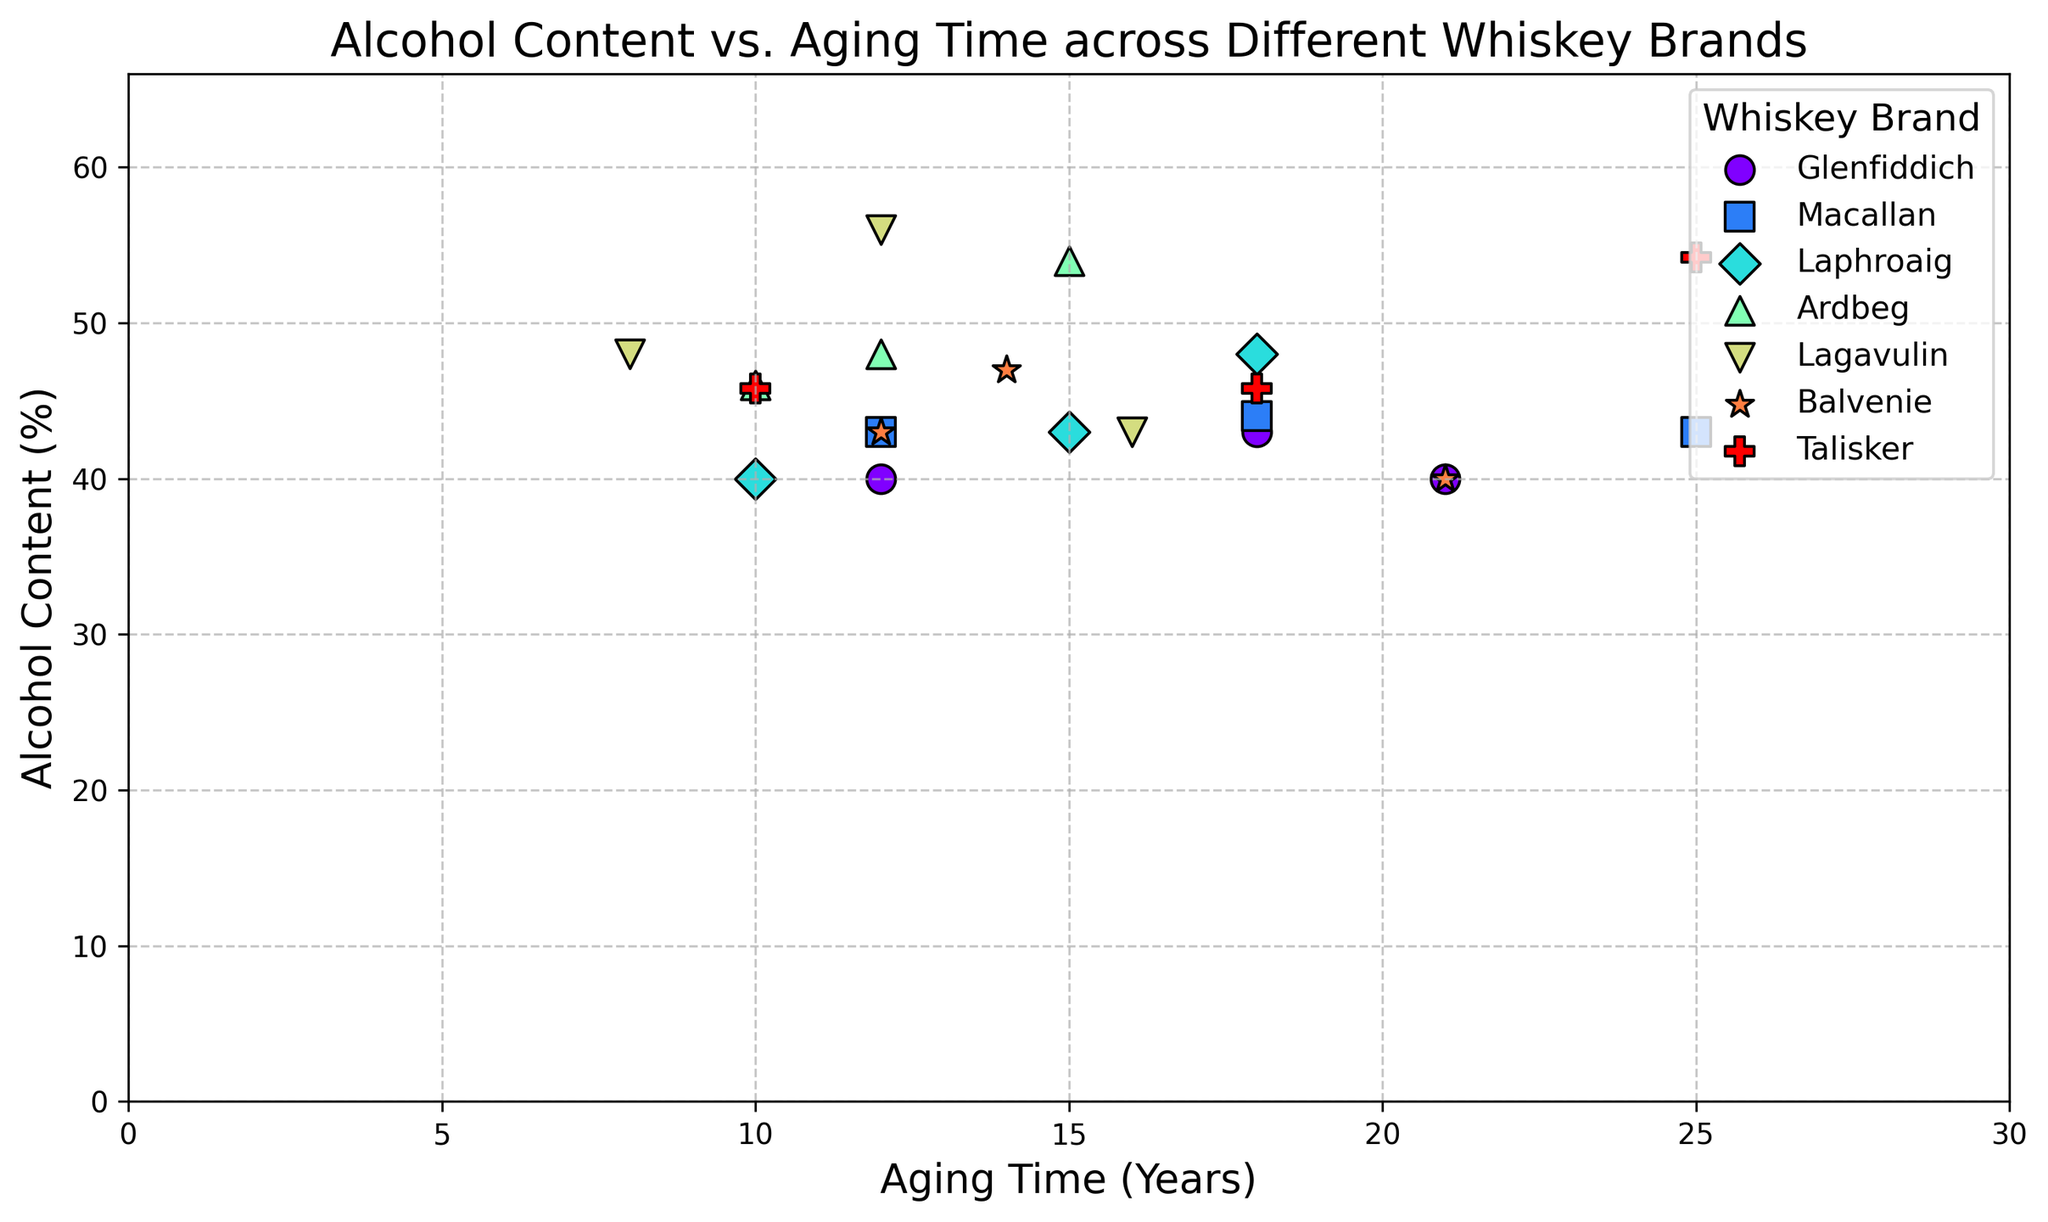What's the brand with the highest alcohol content? Among the plotted points, find and compare the highest y-axis value (Alcohol Content). Identifying Lagavulin with an alcohol content of 56% at 12 years aging.
Answer: Lagavulin Which whiskey brand has the most consistent alcohol content across different aging times? Consistency can be visually assessed by identifying the brand with points closely clustered along the y-axis. Talisker maintains an alcohol content around 45.8% throughout.
Answer: Talisker What is the average alcohol content of Glenfiddich whiskies? Glenfiddich has alcohol contents of 40%, 43%, and 40%. The average is calculated as (40+43+40)/3.
Answer: 41% Is there a brand where older whiskies also have higher alcohol content? Check the trend for each brand, observing if alcohol content increases with aging time. Lagavulin shows a rise from 48% at 8 years to 56% at 12 years, then drops at 16 years.
Answer: Lagavulin Which has higher alcohol content at 12 years, Macallan or Balvenie? Compare the y-axis values for 12-year-old Macallan (43%) and 12-year-old Balvenie (43%). Both are the same.
Answer: Both equal Which brand shows the largest range of alcohol content over different aging times? Identify the brand with the largest difference between highest and lowest y-values. Ardbeg ranges from 46% to 54%.
Answer: Ardbeg At 18 years of aging, which brand has the highest alcohol content? Compare alcohol content of 18-year-old whiskies. Lagavulin (56%) is the highest.
Answer: Lagavulin How does the alcohol content change with aging in Macallan whiskies? Plot points for Macallan show 43% at 12, 44% at 18, and 43% at 25. It slightly increases at 18 years but returns to 43% at 25 years.
Answer: Slight Increase then Same What is the difference in alcohol content between the oldest and youngest whiskies of Talisker? Measure and calculate the difference between 25 years at 54.2% and 10 years at 45.8%. The difference is 54.2% - 45.8%.
Answer: 8.4% Which brand’s whiskies at 15 years or older consistently have higher alcohol contents? Compare brands with whiskies aged 15+ years. Laphroaig has 43% at 15 and 48% at 18, consistently high.
Answer: Laphroaig 